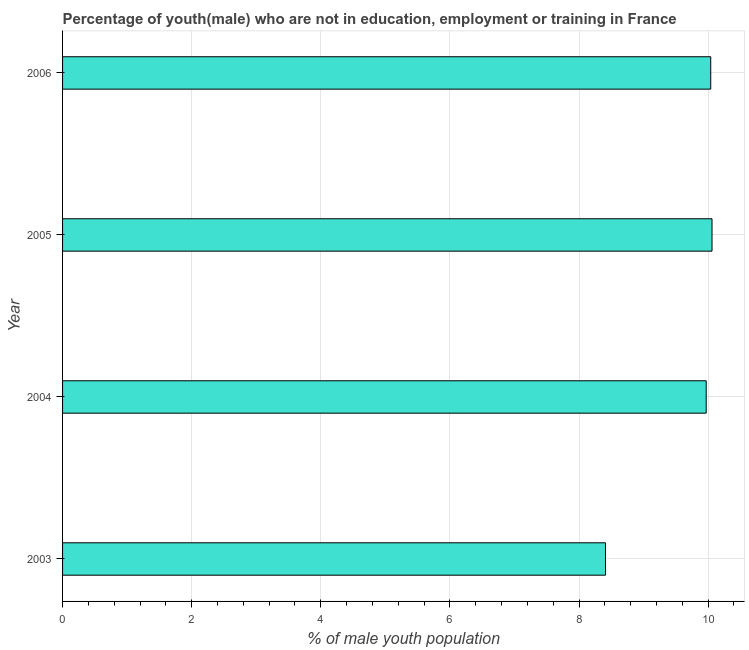Does the graph contain any zero values?
Give a very brief answer. No. What is the title of the graph?
Ensure brevity in your answer.  Percentage of youth(male) who are not in education, employment or training in France. What is the label or title of the X-axis?
Your answer should be compact. % of male youth population. What is the label or title of the Y-axis?
Provide a short and direct response. Year. What is the unemployed male youth population in 2004?
Your response must be concise. 9.97. Across all years, what is the maximum unemployed male youth population?
Ensure brevity in your answer.  10.06. Across all years, what is the minimum unemployed male youth population?
Make the answer very short. 8.41. In which year was the unemployed male youth population minimum?
Offer a very short reply. 2003. What is the sum of the unemployed male youth population?
Offer a very short reply. 38.48. What is the difference between the unemployed male youth population in 2005 and 2006?
Offer a very short reply. 0.02. What is the average unemployed male youth population per year?
Your answer should be very brief. 9.62. What is the median unemployed male youth population?
Your answer should be compact. 10.01. What is the ratio of the unemployed male youth population in 2003 to that in 2004?
Your answer should be very brief. 0.84. Is the unemployed male youth population in 2004 less than that in 2005?
Make the answer very short. Yes. Is the difference between the unemployed male youth population in 2003 and 2005 greater than the difference between any two years?
Provide a short and direct response. Yes. Is the sum of the unemployed male youth population in 2003 and 2006 greater than the maximum unemployed male youth population across all years?
Provide a succinct answer. Yes. What is the difference between the highest and the lowest unemployed male youth population?
Your answer should be very brief. 1.65. How many bars are there?
Ensure brevity in your answer.  4. Are the values on the major ticks of X-axis written in scientific E-notation?
Provide a short and direct response. No. What is the % of male youth population of 2003?
Offer a terse response. 8.41. What is the % of male youth population of 2004?
Make the answer very short. 9.97. What is the % of male youth population in 2005?
Your answer should be compact. 10.06. What is the % of male youth population in 2006?
Provide a short and direct response. 10.04. What is the difference between the % of male youth population in 2003 and 2004?
Ensure brevity in your answer.  -1.56. What is the difference between the % of male youth population in 2003 and 2005?
Ensure brevity in your answer.  -1.65. What is the difference between the % of male youth population in 2003 and 2006?
Keep it short and to the point. -1.63. What is the difference between the % of male youth population in 2004 and 2005?
Make the answer very short. -0.09. What is the difference between the % of male youth population in 2004 and 2006?
Keep it short and to the point. -0.07. What is the difference between the % of male youth population in 2005 and 2006?
Keep it short and to the point. 0.02. What is the ratio of the % of male youth population in 2003 to that in 2004?
Provide a short and direct response. 0.84. What is the ratio of the % of male youth population in 2003 to that in 2005?
Your answer should be compact. 0.84. What is the ratio of the % of male youth population in 2003 to that in 2006?
Your answer should be very brief. 0.84. What is the ratio of the % of male youth population in 2004 to that in 2005?
Offer a terse response. 0.99. What is the ratio of the % of male youth population in 2004 to that in 2006?
Your response must be concise. 0.99. 